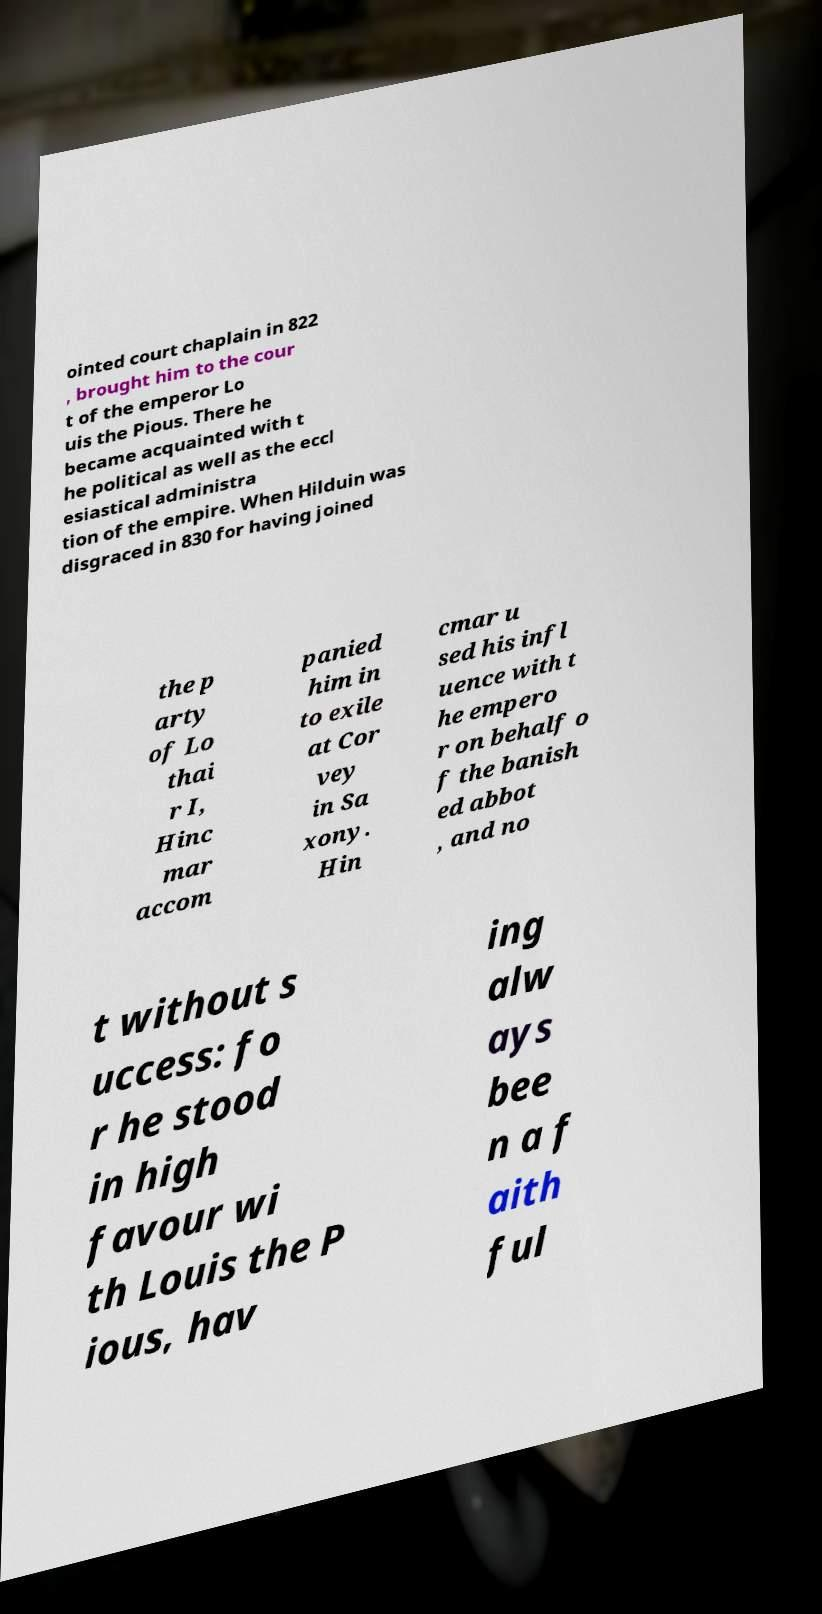Can you accurately transcribe the text from the provided image for me? ointed court chaplain in 822 , brought him to the cour t of the emperor Lo uis the Pious. There he became acquainted with t he political as well as the eccl esiastical administra tion of the empire. When Hilduin was disgraced in 830 for having joined the p arty of Lo thai r I, Hinc mar accom panied him in to exile at Cor vey in Sa xony. Hin cmar u sed his infl uence with t he empero r on behalf o f the banish ed abbot , and no t without s uccess: fo r he stood in high favour wi th Louis the P ious, hav ing alw ays bee n a f aith ful 